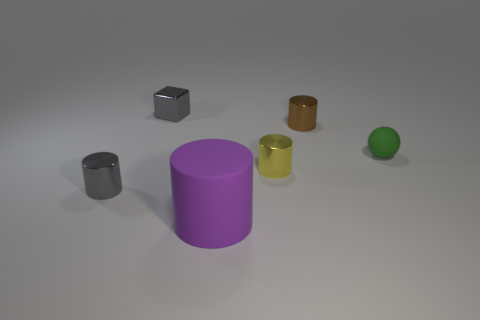Subtract 1 cylinders. How many cylinders are left? 3 Subtract all purple cubes. Subtract all gray balls. How many cubes are left? 1 Add 2 purple rubber things. How many objects exist? 8 Subtract all spheres. How many objects are left? 5 Add 4 big brown rubber cylinders. How many big brown rubber cylinders exist? 4 Subtract 0 cyan spheres. How many objects are left? 6 Subtract all tiny balls. Subtract all tiny objects. How many objects are left? 0 Add 5 purple rubber cylinders. How many purple rubber cylinders are left? 6 